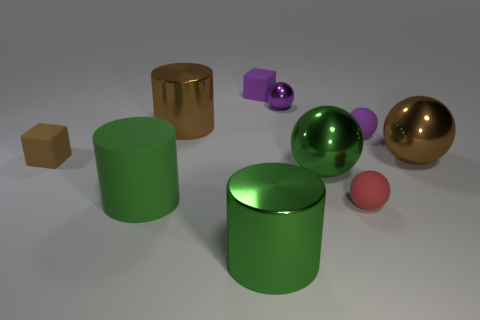Subtract 1 spheres. How many spheres are left? 4 Subtract all green spheres. How many spheres are left? 4 Subtract all brown shiny balls. How many balls are left? 4 Subtract all cyan spheres. Subtract all red cylinders. How many spheres are left? 5 Subtract all blocks. How many objects are left? 8 Subtract all big yellow matte cylinders. Subtract all purple spheres. How many objects are left? 8 Add 3 large matte things. How many large matte things are left? 4 Add 6 purple balls. How many purple balls exist? 8 Subtract 0 purple cylinders. How many objects are left? 10 